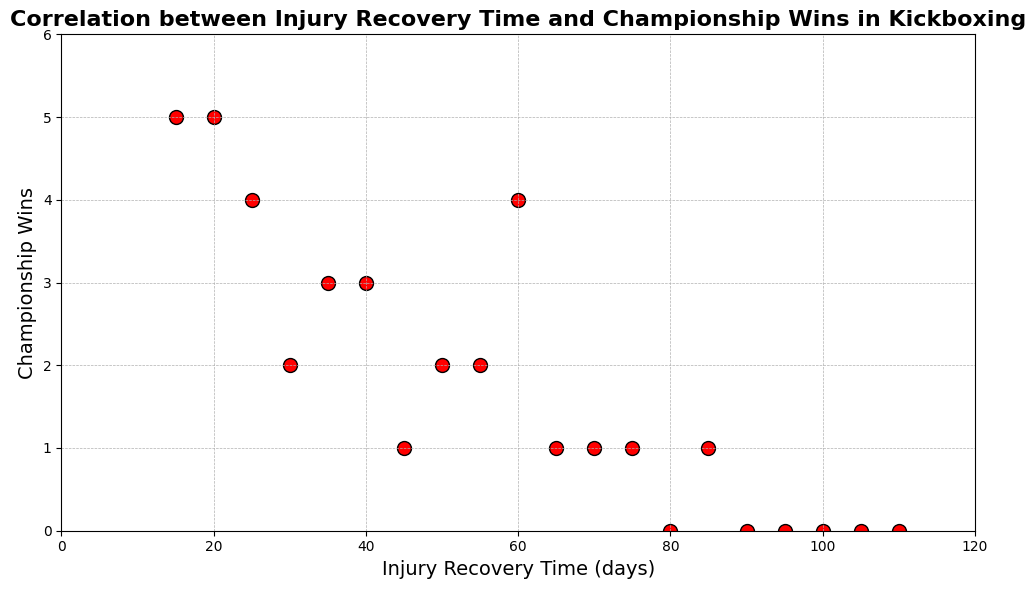Which injury recovery time has the highest number of championship wins? The scatter plot shows the highest number of championship wins at 5, which corresponds to injury recovery times of 15 and 20 days.
Answer: 15 and 20 days Does a longer injury recovery time generally lead to more championship wins? Observing the scatter plot, most longer injury recovery times (above 60 days) have 0 or 1 championship win, suggesting that longer recovery times do not generally lead to more wins.
Answer: No Are there any points where injury recovery time and championship wins are both zero? The figure shows no data points where both axes are zero.
Answer: No What is the range of championship wins for recovery times less than 30 days? Looking at the plot, the recovery times less than 30 days have championship wins ranging from 2 to 5.
Answer: 2 to 5 What is the median number of championship wins for recovery times greater than 60 days? First, find the championship wins for recovery times greater than 60 days, which are [0, 0, 0, 0, 0, 1, 1, 1]. The median is the middle value when they are sorted: 0.5 (average of 0 and 1).
Answer: 0.5 Compare the number of championship wins for recovery times of 45 days and 50 days. The scatter plot shows that 45 days corresponds to 1 championship win, and 50 days corresponds to 2 championship wins.
Answer: 50 days has more wins (2 vs 1) Is there a visible correlation between shorter recovery times and higher championship wins? The data points with shorter recovery times (below 40 days) show higher championship wins, suggesting a negative correlation between recovery time length and championship wins.
Answer: Yes What injury recovery time has exactly 3 championship wins? The scatter plot shows that recovery times of 35 and 40 days both have exactly 3 championship wins.
Answer: 35 and 40 days 